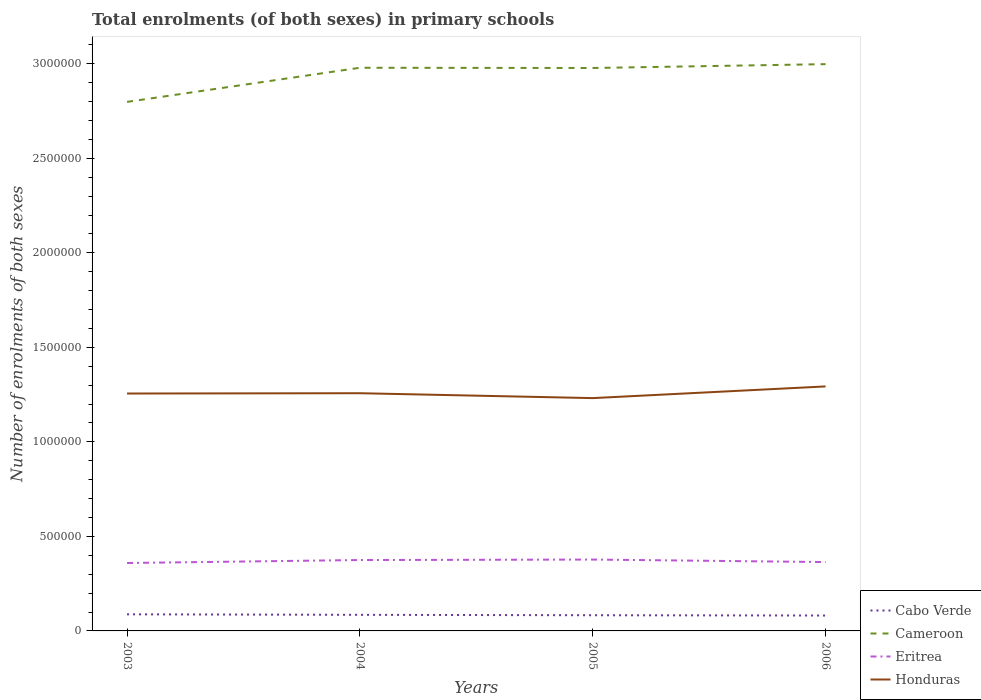Is the number of lines equal to the number of legend labels?
Provide a short and direct response. Yes. Across all years, what is the maximum number of enrolments in primary schools in Cameroon?
Your answer should be compact. 2.80e+06. In which year was the number of enrolments in primary schools in Cabo Verde maximum?
Your answer should be compact. 2006. What is the total number of enrolments in primary schools in Honduras in the graph?
Your response must be concise. -1499. What is the difference between the highest and the second highest number of enrolments in primary schools in Honduras?
Give a very brief answer. 6.18e+04. Is the number of enrolments in primary schools in Cabo Verde strictly greater than the number of enrolments in primary schools in Honduras over the years?
Offer a very short reply. Yes. How many years are there in the graph?
Your answer should be compact. 4. Does the graph contain any zero values?
Give a very brief answer. No. Does the graph contain grids?
Provide a succinct answer. No. How many legend labels are there?
Offer a very short reply. 4. What is the title of the graph?
Ensure brevity in your answer.  Total enrolments (of both sexes) in primary schools. Does "Libya" appear as one of the legend labels in the graph?
Your response must be concise. No. What is the label or title of the Y-axis?
Provide a short and direct response. Number of enrolments of both sexes. What is the Number of enrolments of both sexes of Cabo Verde in 2003?
Provide a short and direct response. 8.78e+04. What is the Number of enrolments of both sexes of Cameroon in 2003?
Your response must be concise. 2.80e+06. What is the Number of enrolments of both sexes of Eritrea in 2003?
Give a very brief answer. 3.59e+05. What is the Number of enrolments of both sexes in Honduras in 2003?
Your answer should be very brief. 1.26e+06. What is the Number of enrolments of both sexes in Cabo Verde in 2004?
Provide a short and direct response. 8.51e+04. What is the Number of enrolments of both sexes of Cameroon in 2004?
Your answer should be compact. 2.98e+06. What is the Number of enrolments of both sexes in Eritrea in 2004?
Provide a succinct answer. 3.75e+05. What is the Number of enrolments of both sexes of Honduras in 2004?
Your answer should be very brief. 1.26e+06. What is the Number of enrolments of both sexes in Cabo Verde in 2005?
Ensure brevity in your answer.  8.30e+04. What is the Number of enrolments of both sexes in Cameroon in 2005?
Make the answer very short. 2.98e+06. What is the Number of enrolments of both sexes of Eritrea in 2005?
Offer a terse response. 3.78e+05. What is the Number of enrolments of both sexes in Honduras in 2005?
Provide a short and direct response. 1.23e+06. What is the Number of enrolments of both sexes of Cabo Verde in 2006?
Your response must be concise. 8.14e+04. What is the Number of enrolments of both sexes in Cameroon in 2006?
Provide a short and direct response. 3.00e+06. What is the Number of enrolments of both sexes of Eritrea in 2006?
Ensure brevity in your answer.  3.64e+05. What is the Number of enrolments of both sexes in Honduras in 2006?
Provide a short and direct response. 1.29e+06. Across all years, what is the maximum Number of enrolments of both sexes of Cabo Verde?
Offer a very short reply. 8.78e+04. Across all years, what is the maximum Number of enrolments of both sexes of Cameroon?
Your answer should be compact. 3.00e+06. Across all years, what is the maximum Number of enrolments of both sexes of Eritrea?
Give a very brief answer. 3.78e+05. Across all years, what is the maximum Number of enrolments of both sexes in Honduras?
Your response must be concise. 1.29e+06. Across all years, what is the minimum Number of enrolments of both sexes in Cabo Verde?
Offer a very short reply. 8.14e+04. Across all years, what is the minimum Number of enrolments of both sexes of Cameroon?
Offer a very short reply. 2.80e+06. Across all years, what is the minimum Number of enrolments of both sexes in Eritrea?
Your response must be concise. 3.59e+05. Across all years, what is the minimum Number of enrolments of both sexes of Honduras?
Offer a terse response. 1.23e+06. What is the total Number of enrolments of both sexes of Cabo Verde in the graph?
Ensure brevity in your answer.  3.37e+05. What is the total Number of enrolments of both sexes of Cameroon in the graph?
Offer a very short reply. 1.18e+07. What is the total Number of enrolments of both sexes in Eritrea in the graph?
Make the answer very short. 1.48e+06. What is the total Number of enrolments of both sexes of Honduras in the graph?
Ensure brevity in your answer.  5.04e+06. What is the difference between the Number of enrolments of both sexes of Cabo Verde in 2003 and that in 2004?
Your answer should be compact. 2705. What is the difference between the Number of enrolments of both sexes in Cameroon in 2003 and that in 2004?
Your answer should be very brief. -1.80e+05. What is the difference between the Number of enrolments of both sexes in Eritrea in 2003 and that in 2004?
Provide a succinct answer. -1.57e+04. What is the difference between the Number of enrolments of both sexes in Honduras in 2003 and that in 2004?
Your answer should be very brief. -1499. What is the difference between the Number of enrolments of both sexes of Cabo Verde in 2003 and that in 2005?
Offer a very short reply. 4858. What is the difference between the Number of enrolments of both sexes of Cameroon in 2003 and that in 2005?
Provide a succinct answer. -1.79e+05. What is the difference between the Number of enrolments of both sexes of Eritrea in 2003 and that in 2005?
Provide a succinct answer. -1.82e+04. What is the difference between the Number of enrolments of both sexes in Honduras in 2003 and that in 2005?
Provide a short and direct response. 2.43e+04. What is the difference between the Number of enrolments of both sexes of Cabo Verde in 2003 and that in 2006?
Keep it short and to the point. 6409. What is the difference between the Number of enrolments of both sexes of Cameroon in 2003 and that in 2006?
Offer a very short reply. -2.00e+05. What is the difference between the Number of enrolments of both sexes of Eritrea in 2003 and that in 2006?
Offer a very short reply. -4964. What is the difference between the Number of enrolments of both sexes of Honduras in 2003 and that in 2006?
Your answer should be compact. -3.75e+04. What is the difference between the Number of enrolments of both sexes in Cabo Verde in 2004 and that in 2005?
Make the answer very short. 2153. What is the difference between the Number of enrolments of both sexes of Cameroon in 2004 and that in 2005?
Keep it short and to the point. 1230. What is the difference between the Number of enrolments of both sexes in Eritrea in 2004 and that in 2005?
Provide a short and direct response. -2515. What is the difference between the Number of enrolments of both sexes of Honduras in 2004 and that in 2005?
Offer a very short reply. 2.58e+04. What is the difference between the Number of enrolments of both sexes in Cabo Verde in 2004 and that in 2006?
Offer a very short reply. 3704. What is the difference between the Number of enrolments of both sexes of Cameroon in 2004 and that in 2006?
Provide a succinct answer. -1.91e+04. What is the difference between the Number of enrolments of both sexes in Eritrea in 2004 and that in 2006?
Your response must be concise. 1.07e+04. What is the difference between the Number of enrolments of both sexes of Honduras in 2004 and that in 2006?
Ensure brevity in your answer.  -3.60e+04. What is the difference between the Number of enrolments of both sexes in Cabo Verde in 2005 and that in 2006?
Ensure brevity in your answer.  1551. What is the difference between the Number of enrolments of both sexes in Cameroon in 2005 and that in 2006?
Your answer should be compact. -2.04e+04. What is the difference between the Number of enrolments of both sexes of Eritrea in 2005 and that in 2006?
Provide a short and direct response. 1.32e+04. What is the difference between the Number of enrolments of both sexes of Honduras in 2005 and that in 2006?
Offer a terse response. -6.18e+04. What is the difference between the Number of enrolments of both sexes of Cabo Verde in 2003 and the Number of enrolments of both sexes of Cameroon in 2004?
Make the answer very short. -2.89e+06. What is the difference between the Number of enrolments of both sexes of Cabo Verde in 2003 and the Number of enrolments of both sexes of Eritrea in 2004?
Give a very brief answer. -2.87e+05. What is the difference between the Number of enrolments of both sexes of Cabo Verde in 2003 and the Number of enrolments of both sexes of Honduras in 2004?
Your answer should be very brief. -1.17e+06. What is the difference between the Number of enrolments of both sexes of Cameroon in 2003 and the Number of enrolments of both sexes of Eritrea in 2004?
Keep it short and to the point. 2.42e+06. What is the difference between the Number of enrolments of both sexes of Cameroon in 2003 and the Number of enrolments of both sexes of Honduras in 2004?
Provide a short and direct response. 1.54e+06. What is the difference between the Number of enrolments of both sexes in Eritrea in 2003 and the Number of enrolments of both sexes in Honduras in 2004?
Your response must be concise. -8.98e+05. What is the difference between the Number of enrolments of both sexes of Cabo Verde in 2003 and the Number of enrolments of both sexes of Cameroon in 2005?
Provide a short and direct response. -2.89e+06. What is the difference between the Number of enrolments of both sexes in Cabo Verde in 2003 and the Number of enrolments of both sexes in Eritrea in 2005?
Give a very brief answer. -2.90e+05. What is the difference between the Number of enrolments of both sexes of Cabo Verde in 2003 and the Number of enrolments of both sexes of Honduras in 2005?
Your answer should be very brief. -1.14e+06. What is the difference between the Number of enrolments of both sexes of Cameroon in 2003 and the Number of enrolments of both sexes of Eritrea in 2005?
Keep it short and to the point. 2.42e+06. What is the difference between the Number of enrolments of both sexes of Cameroon in 2003 and the Number of enrolments of both sexes of Honduras in 2005?
Provide a succinct answer. 1.57e+06. What is the difference between the Number of enrolments of both sexes of Eritrea in 2003 and the Number of enrolments of both sexes of Honduras in 2005?
Your answer should be compact. -8.72e+05. What is the difference between the Number of enrolments of both sexes of Cabo Verde in 2003 and the Number of enrolments of both sexes of Cameroon in 2006?
Make the answer very short. -2.91e+06. What is the difference between the Number of enrolments of both sexes in Cabo Verde in 2003 and the Number of enrolments of both sexes in Eritrea in 2006?
Your answer should be compact. -2.76e+05. What is the difference between the Number of enrolments of both sexes of Cabo Verde in 2003 and the Number of enrolments of both sexes of Honduras in 2006?
Provide a short and direct response. -1.21e+06. What is the difference between the Number of enrolments of both sexes in Cameroon in 2003 and the Number of enrolments of both sexes in Eritrea in 2006?
Provide a short and direct response. 2.43e+06. What is the difference between the Number of enrolments of both sexes of Cameroon in 2003 and the Number of enrolments of both sexes of Honduras in 2006?
Give a very brief answer. 1.51e+06. What is the difference between the Number of enrolments of both sexes in Eritrea in 2003 and the Number of enrolments of both sexes in Honduras in 2006?
Offer a terse response. -9.34e+05. What is the difference between the Number of enrolments of both sexes of Cabo Verde in 2004 and the Number of enrolments of both sexes of Cameroon in 2005?
Offer a very short reply. -2.89e+06. What is the difference between the Number of enrolments of both sexes of Cabo Verde in 2004 and the Number of enrolments of both sexes of Eritrea in 2005?
Provide a short and direct response. -2.92e+05. What is the difference between the Number of enrolments of both sexes of Cabo Verde in 2004 and the Number of enrolments of both sexes of Honduras in 2005?
Make the answer very short. -1.15e+06. What is the difference between the Number of enrolments of both sexes in Cameroon in 2004 and the Number of enrolments of both sexes in Eritrea in 2005?
Provide a succinct answer. 2.60e+06. What is the difference between the Number of enrolments of both sexes of Cameroon in 2004 and the Number of enrolments of both sexes of Honduras in 2005?
Provide a short and direct response. 1.75e+06. What is the difference between the Number of enrolments of both sexes in Eritrea in 2004 and the Number of enrolments of both sexes in Honduras in 2005?
Your answer should be very brief. -8.57e+05. What is the difference between the Number of enrolments of both sexes of Cabo Verde in 2004 and the Number of enrolments of both sexes of Cameroon in 2006?
Ensure brevity in your answer.  -2.91e+06. What is the difference between the Number of enrolments of both sexes in Cabo Verde in 2004 and the Number of enrolments of both sexes in Eritrea in 2006?
Offer a terse response. -2.79e+05. What is the difference between the Number of enrolments of both sexes of Cabo Verde in 2004 and the Number of enrolments of both sexes of Honduras in 2006?
Make the answer very short. -1.21e+06. What is the difference between the Number of enrolments of both sexes of Cameroon in 2004 and the Number of enrolments of both sexes of Eritrea in 2006?
Give a very brief answer. 2.61e+06. What is the difference between the Number of enrolments of both sexes in Cameroon in 2004 and the Number of enrolments of both sexes in Honduras in 2006?
Your answer should be very brief. 1.69e+06. What is the difference between the Number of enrolments of both sexes in Eritrea in 2004 and the Number of enrolments of both sexes in Honduras in 2006?
Offer a very short reply. -9.18e+05. What is the difference between the Number of enrolments of both sexes in Cabo Verde in 2005 and the Number of enrolments of both sexes in Cameroon in 2006?
Offer a terse response. -2.92e+06. What is the difference between the Number of enrolments of both sexes in Cabo Verde in 2005 and the Number of enrolments of both sexes in Eritrea in 2006?
Provide a succinct answer. -2.81e+05. What is the difference between the Number of enrolments of both sexes of Cabo Verde in 2005 and the Number of enrolments of both sexes of Honduras in 2006?
Offer a very short reply. -1.21e+06. What is the difference between the Number of enrolments of both sexes of Cameroon in 2005 and the Number of enrolments of both sexes of Eritrea in 2006?
Offer a terse response. 2.61e+06. What is the difference between the Number of enrolments of both sexes of Cameroon in 2005 and the Number of enrolments of both sexes of Honduras in 2006?
Provide a succinct answer. 1.68e+06. What is the difference between the Number of enrolments of both sexes in Eritrea in 2005 and the Number of enrolments of both sexes in Honduras in 2006?
Make the answer very short. -9.16e+05. What is the average Number of enrolments of both sexes of Cabo Verde per year?
Your response must be concise. 8.44e+04. What is the average Number of enrolments of both sexes in Cameroon per year?
Ensure brevity in your answer.  2.94e+06. What is the average Number of enrolments of both sexes of Eritrea per year?
Your answer should be compact. 3.69e+05. What is the average Number of enrolments of both sexes in Honduras per year?
Give a very brief answer. 1.26e+06. In the year 2003, what is the difference between the Number of enrolments of both sexes of Cabo Verde and Number of enrolments of both sexes of Cameroon?
Ensure brevity in your answer.  -2.71e+06. In the year 2003, what is the difference between the Number of enrolments of both sexes in Cabo Verde and Number of enrolments of both sexes in Eritrea?
Give a very brief answer. -2.71e+05. In the year 2003, what is the difference between the Number of enrolments of both sexes of Cabo Verde and Number of enrolments of both sexes of Honduras?
Your response must be concise. -1.17e+06. In the year 2003, what is the difference between the Number of enrolments of both sexes of Cameroon and Number of enrolments of both sexes of Eritrea?
Your answer should be compact. 2.44e+06. In the year 2003, what is the difference between the Number of enrolments of both sexes of Cameroon and Number of enrolments of both sexes of Honduras?
Provide a short and direct response. 1.54e+06. In the year 2003, what is the difference between the Number of enrolments of both sexes of Eritrea and Number of enrolments of both sexes of Honduras?
Provide a succinct answer. -8.97e+05. In the year 2004, what is the difference between the Number of enrolments of both sexes in Cabo Verde and Number of enrolments of both sexes in Cameroon?
Provide a short and direct response. -2.89e+06. In the year 2004, what is the difference between the Number of enrolments of both sexes of Cabo Verde and Number of enrolments of both sexes of Eritrea?
Make the answer very short. -2.90e+05. In the year 2004, what is the difference between the Number of enrolments of both sexes in Cabo Verde and Number of enrolments of both sexes in Honduras?
Keep it short and to the point. -1.17e+06. In the year 2004, what is the difference between the Number of enrolments of both sexes of Cameroon and Number of enrolments of both sexes of Eritrea?
Provide a short and direct response. 2.60e+06. In the year 2004, what is the difference between the Number of enrolments of both sexes of Cameroon and Number of enrolments of both sexes of Honduras?
Offer a very short reply. 1.72e+06. In the year 2004, what is the difference between the Number of enrolments of both sexes of Eritrea and Number of enrolments of both sexes of Honduras?
Give a very brief answer. -8.82e+05. In the year 2005, what is the difference between the Number of enrolments of both sexes of Cabo Verde and Number of enrolments of both sexes of Cameroon?
Your response must be concise. -2.89e+06. In the year 2005, what is the difference between the Number of enrolments of both sexes of Cabo Verde and Number of enrolments of both sexes of Eritrea?
Ensure brevity in your answer.  -2.95e+05. In the year 2005, what is the difference between the Number of enrolments of both sexes in Cabo Verde and Number of enrolments of both sexes in Honduras?
Provide a succinct answer. -1.15e+06. In the year 2005, what is the difference between the Number of enrolments of both sexes of Cameroon and Number of enrolments of both sexes of Eritrea?
Offer a terse response. 2.60e+06. In the year 2005, what is the difference between the Number of enrolments of both sexes in Cameroon and Number of enrolments of both sexes in Honduras?
Keep it short and to the point. 1.75e+06. In the year 2005, what is the difference between the Number of enrolments of both sexes in Eritrea and Number of enrolments of both sexes in Honduras?
Your answer should be compact. -8.54e+05. In the year 2006, what is the difference between the Number of enrolments of both sexes in Cabo Verde and Number of enrolments of both sexes in Cameroon?
Give a very brief answer. -2.92e+06. In the year 2006, what is the difference between the Number of enrolments of both sexes in Cabo Verde and Number of enrolments of both sexes in Eritrea?
Your answer should be very brief. -2.83e+05. In the year 2006, what is the difference between the Number of enrolments of both sexes of Cabo Verde and Number of enrolments of both sexes of Honduras?
Provide a succinct answer. -1.21e+06. In the year 2006, what is the difference between the Number of enrolments of both sexes in Cameroon and Number of enrolments of both sexes in Eritrea?
Give a very brief answer. 2.63e+06. In the year 2006, what is the difference between the Number of enrolments of both sexes of Cameroon and Number of enrolments of both sexes of Honduras?
Keep it short and to the point. 1.70e+06. In the year 2006, what is the difference between the Number of enrolments of both sexes in Eritrea and Number of enrolments of both sexes in Honduras?
Your answer should be compact. -9.29e+05. What is the ratio of the Number of enrolments of both sexes of Cabo Verde in 2003 to that in 2004?
Offer a terse response. 1.03. What is the ratio of the Number of enrolments of both sexes in Cameroon in 2003 to that in 2004?
Offer a very short reply. 0.94. What is the ratio of the Number of enrolments of both sexes of Eritrea in 2003 to that in 2004?
Provide a succinct answer. 0.96. What is the ratio of the Number of enrolments of both sexes in Cabo Verde in 2003 to that in 2005?
Your answer should be compact. 1.06. What is the ratio of the Number of enrolments of both sexes in Cameroon in 2003 to that in 2005?
Keep it short and to the point. 0.94. What is the ratio of the Number of enrolments of both sexes of Eritrea in 2003 to that in 2005?
Your answer should be compact. 0.95. What is the ratio of the Number of enrolments of both sexes in Honduras in 2003 to that in 2005?
Ensure brevity in your answer.  1.02. What is the ratio of the Number of enrolments of both sexes in Cabo Verde in 2003 to that in 2006?
Your answer should be very brief. 1.08. What is the ratio of the Number of enrolments of both sexes in Cameroon in 2003 to that in 2006?
Keep it short and to the point. 0.93. What is the ratio of the Number of enrolments of both sexes in Eritrea in 2003 to that in 2006?
Your answer should be very brief. 0.99. What is the ratio of the Number of enrolments of both sexes of Honduras in 2003 to that in 2006?
Provide a short and direct response. 0.97. What is the ratio of the Number of enrolments of both sexes of Cabo Verde in 2004 to that in 2005?
Make the answer very short. 1.03. What is the ratio of the Number of enrolments of both sexes in Cameroon in 2004 to that in 2005?
Offer a very short reply. 1. What is the ratio of the Number of enrolments of both sexes in Eritrea in 2004 to that in 2005?
Make the answer very short. 0.99. What is the ratio of the Number of enrolments of both sexes in Cabo Verde in 2004 to that in 2006?
Keep it short and to the point. 1.05. What is the ratio of the Number of enrolments of both sexes of Eritrea in 2004 to that in 2006?
Provide a succinct answer. 1.03. What is the ratio of the Number of enrolments of both sexes in Honduras in 2004 to that in 2006?
Give a very brief answer. 0.97. What is the ratio of the Number of enrolments of both sexes in Cameroon in 2005 to that in 2006?
Your answer should be very brief. 0.99. What is the ratio of the Number of enrolments of both sexes in Eritrea in 2005 to that in 2006?
Offer a terse response. 1.04. What is the ratio of the Number of enrolments of both sexes of Honduras in 2005 to that in 2006?
Your answer should be very brief. 0.95. What is the difference between the highest and the second highest Number of enrolments of both sexes in Cabo Verde?
Your answer should be compact. 2705. What is the difference between the highest and the second highest Number of enrolments of both sexes in Cameroon?
Keep it short and to the point. 1.91e+04. What is the difference between the highest and the second highest Number of enrolments of both sexes in Eritrea?
Your response must be concise. 2515. What is the difference between the highest and the second highest Number of enrolments of both sexes in Honduras?
Offer a very short reply. 3.60e+04. What is the difference between the highest and the lowest Number of enrolments of both sexes in Cabo Verde?
Your response must be concise. 6409. What is the difference between the highest and the lowest Number of enrolments of both sexes of Cameroon?
Keep it short and to the point. 2.00e+05. What is the difference between the highest and the lowest Number of enrolments of both sexes in Eritrea?
Your answer should be compact. 1.82e+04. What is the difference between the highest and the lowest Number of enrolments of both sexes in Honduras?
Keep it short and to the point. 6.18e+04. 